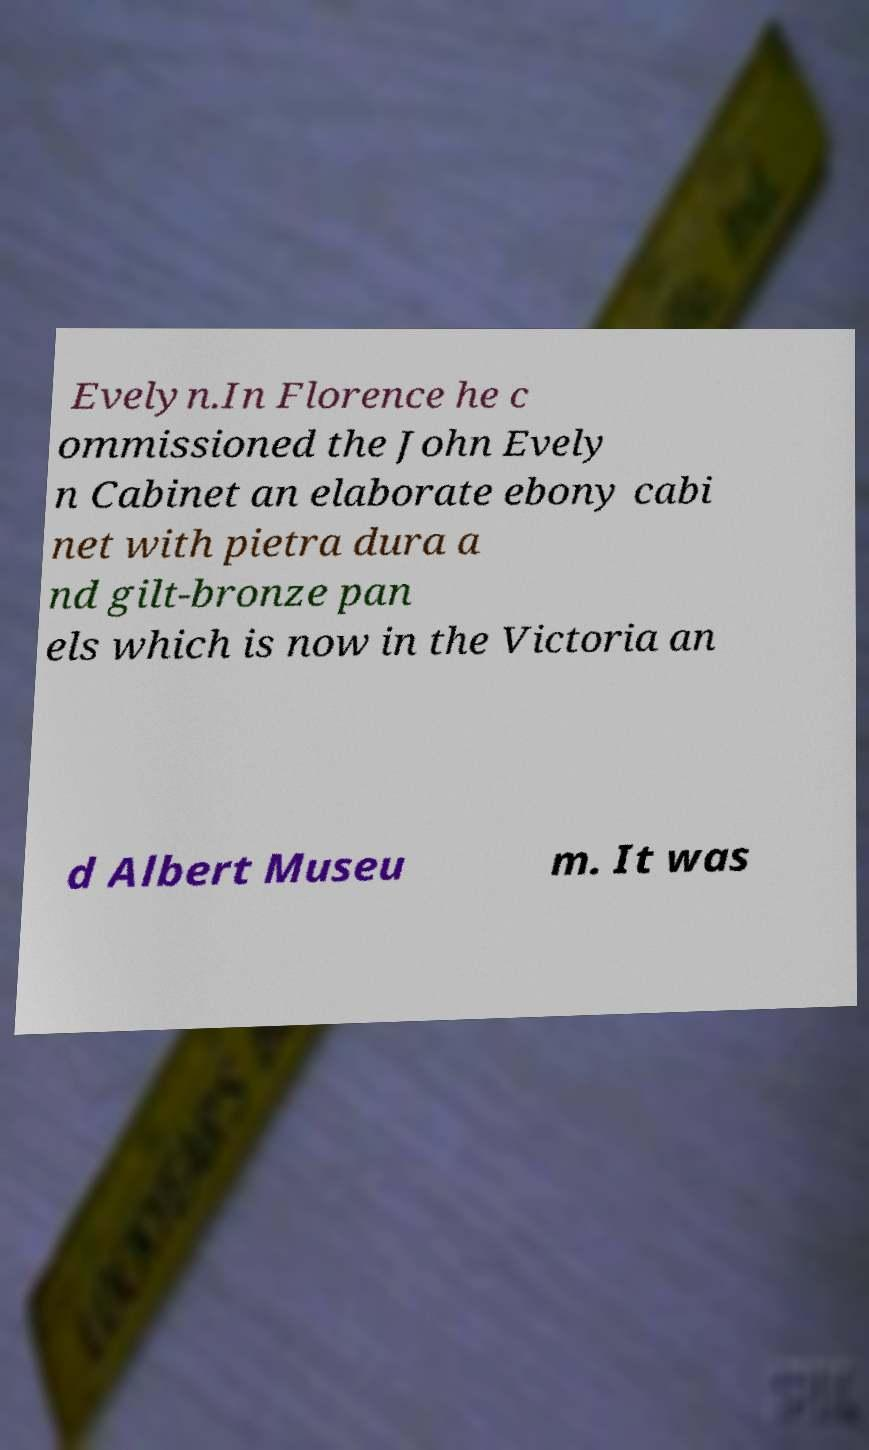Can you read and provide the text displayed in the image?This photo seems to have some interesting text. Can you extract and type it out for me? Evelyn.In Florence he c ommissioned the John Evely n Cabinet an elaborate ebony cabi net with pietra dura a nd gilt-bronze pan els which is now in the Victoria an d Albert Museu m. It was 